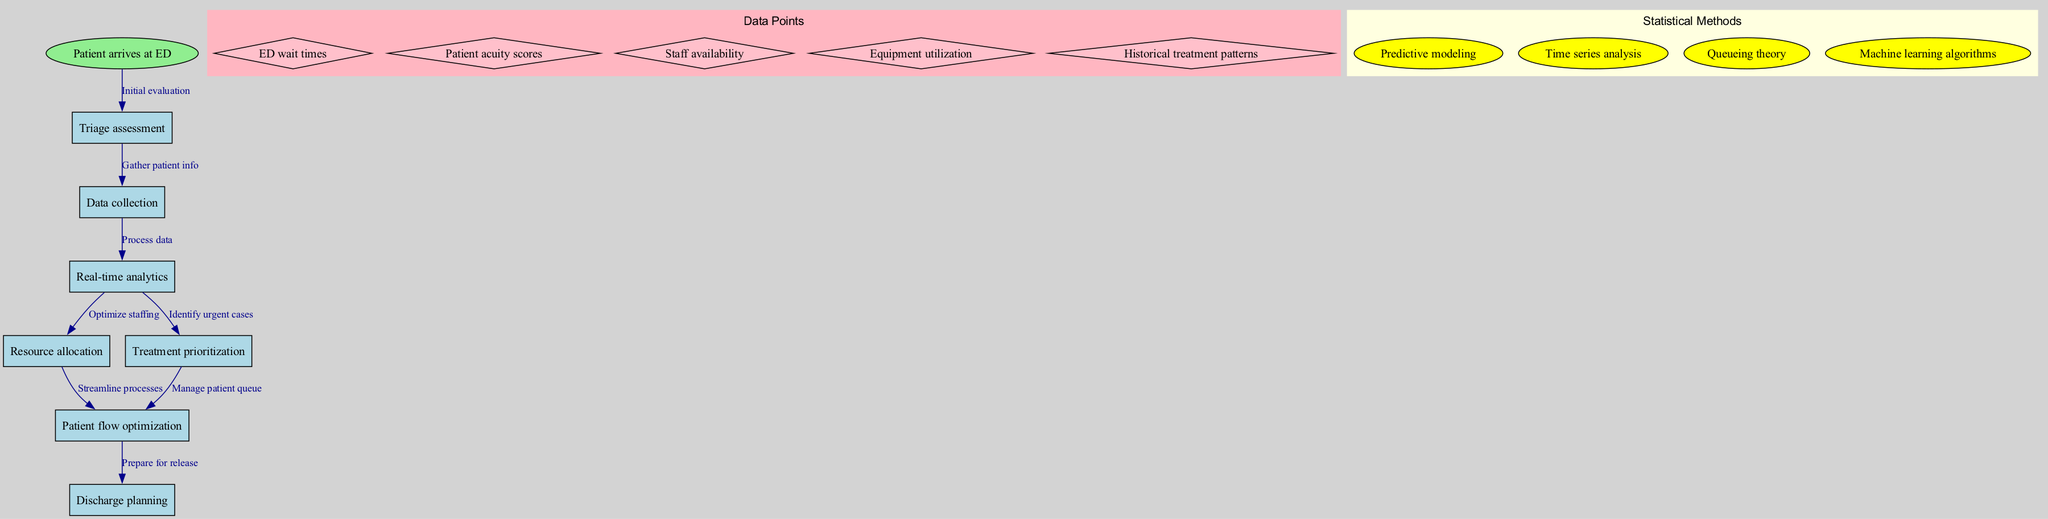What is the starting point of the clinical pathway? The starting point of the clinical pathway is indicated by the label "Patient arrives at ED" in the diagram. This node is positioned at the top, representing the initial event that triggers the following steps.
Answer: Patient arrives at ED How many nodes are present in the diagram? The diagram contains a total of seven nodes, which include one starting point and six subsequent activities, each marked clearly in the flow.
Answer: Seven What type of analysis follows data collection? The diagram shows that after "Data collection," the next step is "Real-time analytics," indicating the type of analysis that immediately follows the data gathering stage.
Answer: Real-time analytics Which node is responsible for managing the patient queue? According to the diagram, "Treatment prioritization" is directly connected to "Patient flow optimization," indicating that this node plays a significant role in managing the patient queue effectively.
Answer: Treatment prioritization What is the relationship between "Resource allocation" and "Patient flow optimization"? The relationship is indicated by an arrow in the diagram that shows "Resource allocation" leads into "Patient flow optimization," illustrating that after staff and resources are allocated, the next focus is on optimizing patient movement through the department.
Answer: Streamline processes How many data points are listed in the diagram? There are five data points presented in the diagram, each representing specific metrics that could be analyzed to improve efficiencies in the emergency department workflow.
Answer: Five Which statistical method is used to identify urgent cases? The method "Machine learning algorithms" is involved in the "Real-time analytics" node, which encompasses identifying urgent cases based on incoming data and established patterns.
Answer: Machine learning algorithms What do we need to prepare for right after "Patient flow optimization"? The diagram shows that "Discharge planning" follows "Patient flow optimization," indicating that after optimizing the movement and care of patients, preparing for their release is the subsequent action.
Answer: Discharge planning What is the label for the edge leading from "Triage assessment" to "Data collection"? The edge leading from "Triage assessment" to "Data collection" is labeled "Gather patient info," illustrating the action taken during this transition in the pathway.
Answer: Gather patient info 